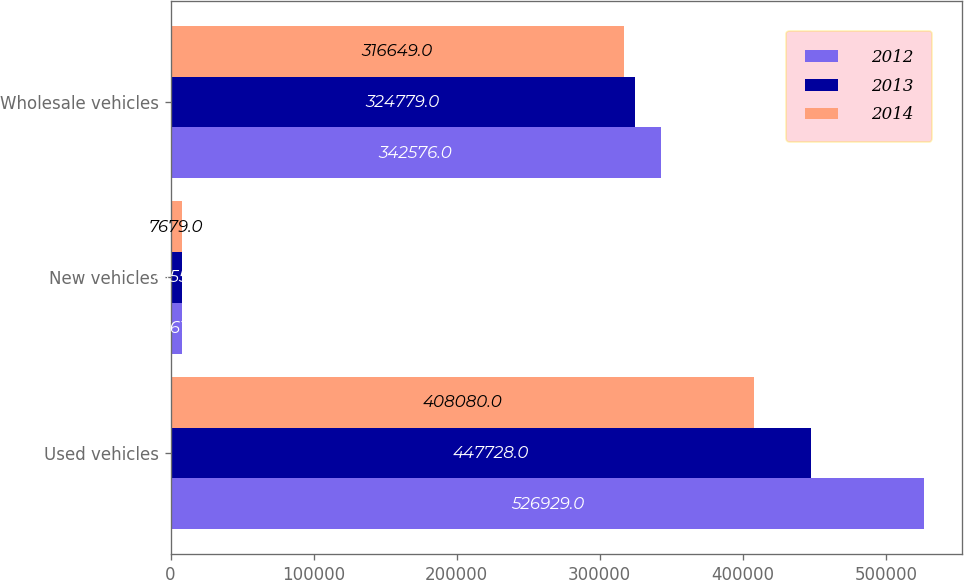<chart> <loc_0><loc_0><loc_500><loc_500><stacked_bar_chart><ecel><fcel>Used vehicles<fcel>New vehicles<fcel>Wholesale vehicles<nl><fcel>2012<fcel>526929<fcel>7761<fcel>342576<nl><fcel>2013<fcel>447728<fcel>7855<fcel>324779<nl><fcel>2014<fcel>408080<fcel>7679<fcel>316649<nl></chart> 